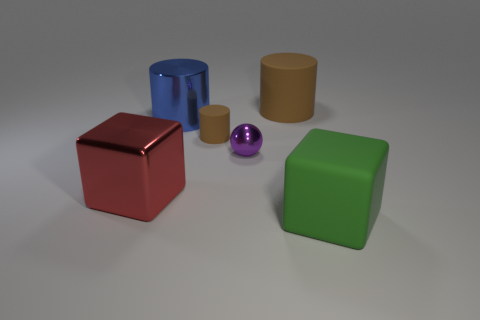Does the small ball have the same material as the large cube that is on the left side of the big blue cylinder? yes 